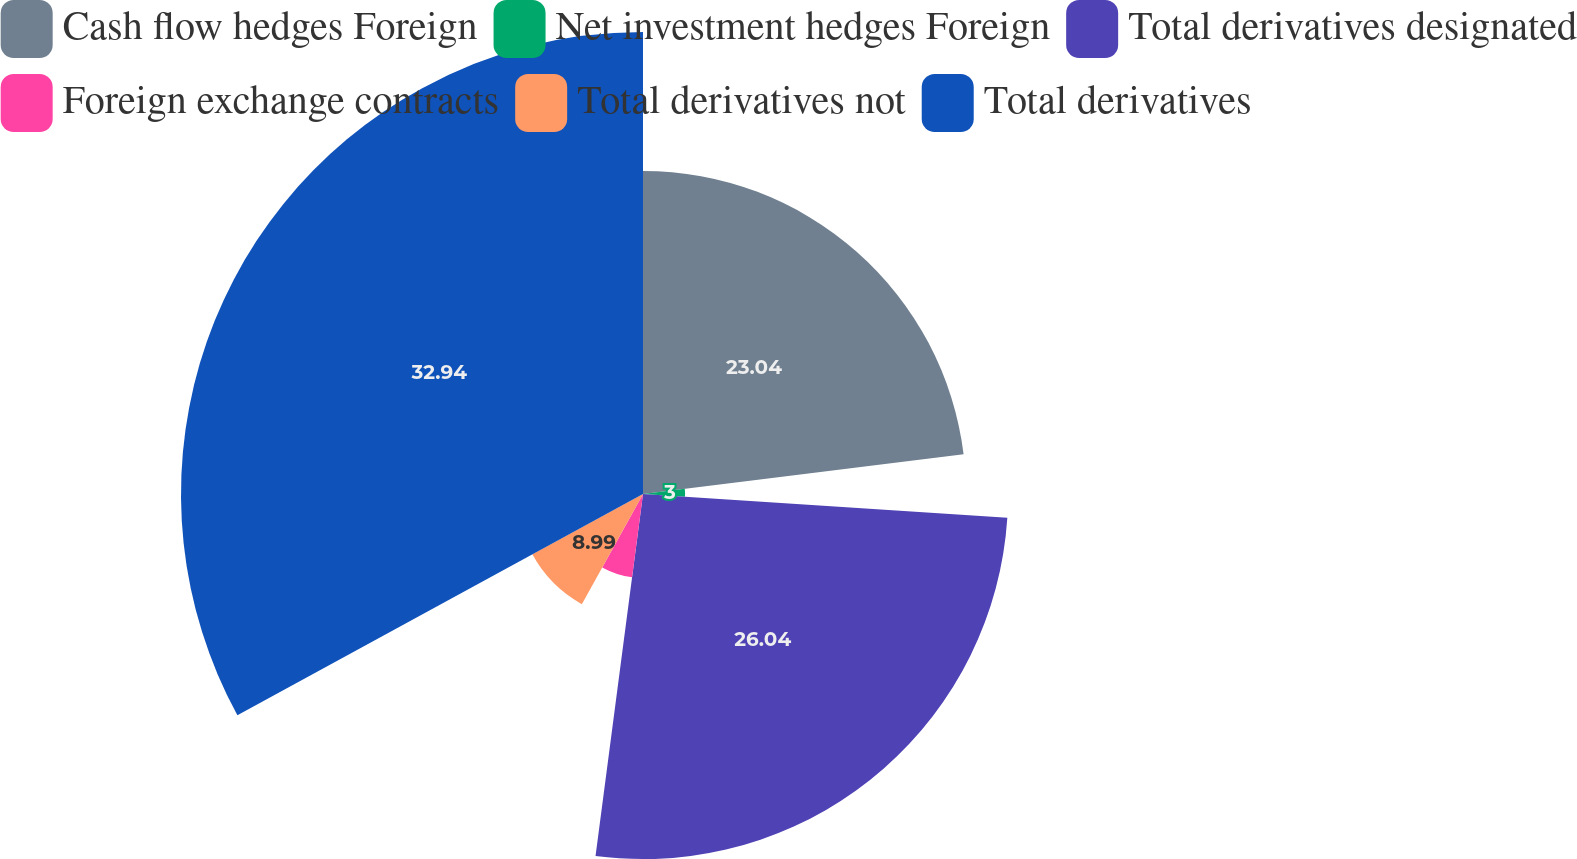Convert chart to OTSL. <chart><loc_0><loc_0><loc_500><loc_500><pie_chart><fcel>Cash flow hedges Foreign<fcel>Net investment hedges Foreign<fcel>Total derivatives designated<fcel>Foreign exchange contracts<fcel>Total derivatives not<fcel>Total derivatives<nl><fcel>23.04%<fcel>3.0%<fcel>26.04%<fcel>5.99%<fcel>8.99%<fcel>32.95%<nl></chart> 